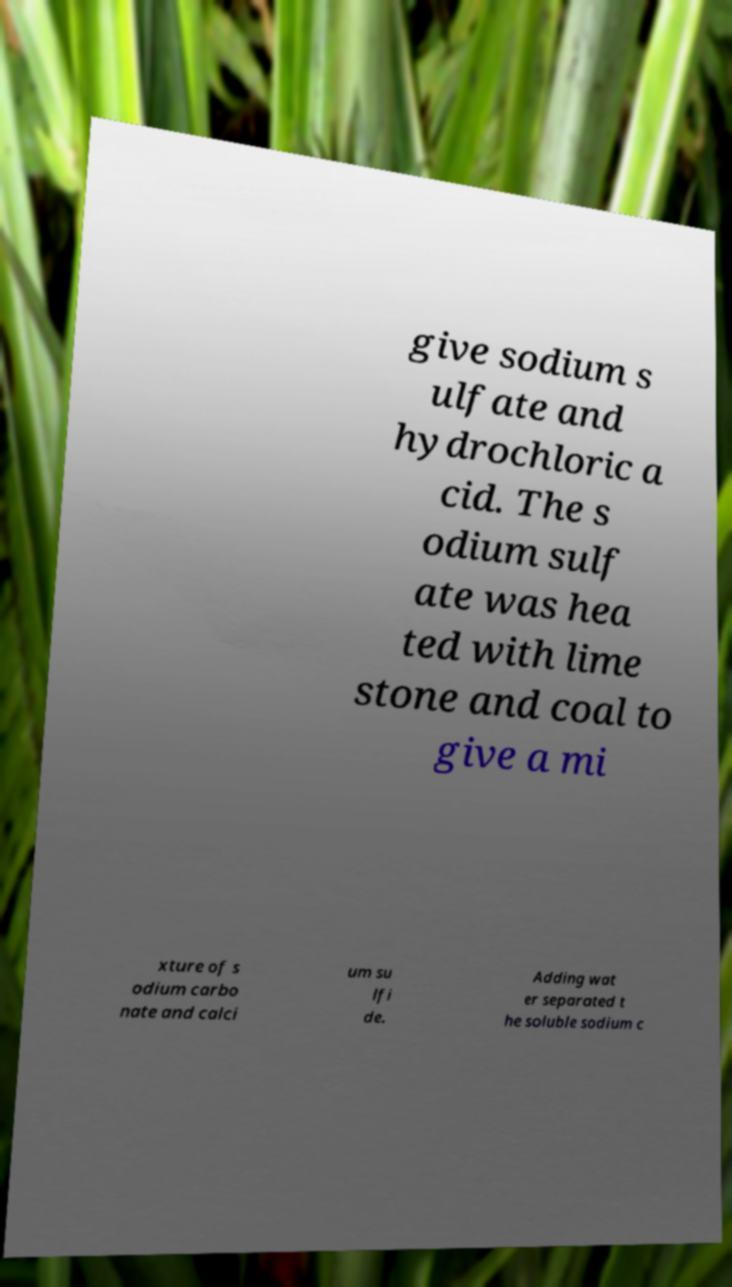Could you assist in decoding the text presented in this image and type it out clearly? give sodium s ulfate and hydrochloric a cid. The s odium sulf ate was hea ted with lime stone and coal to give a mi xture of s odium carbo nate and calci um su lfi de. Adding wat er separated t he soluble sodium c 